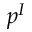Convert formula to latex. <formula><loc_0><loc_0><loc_500><loc_500>p ^ { I }</formula> 